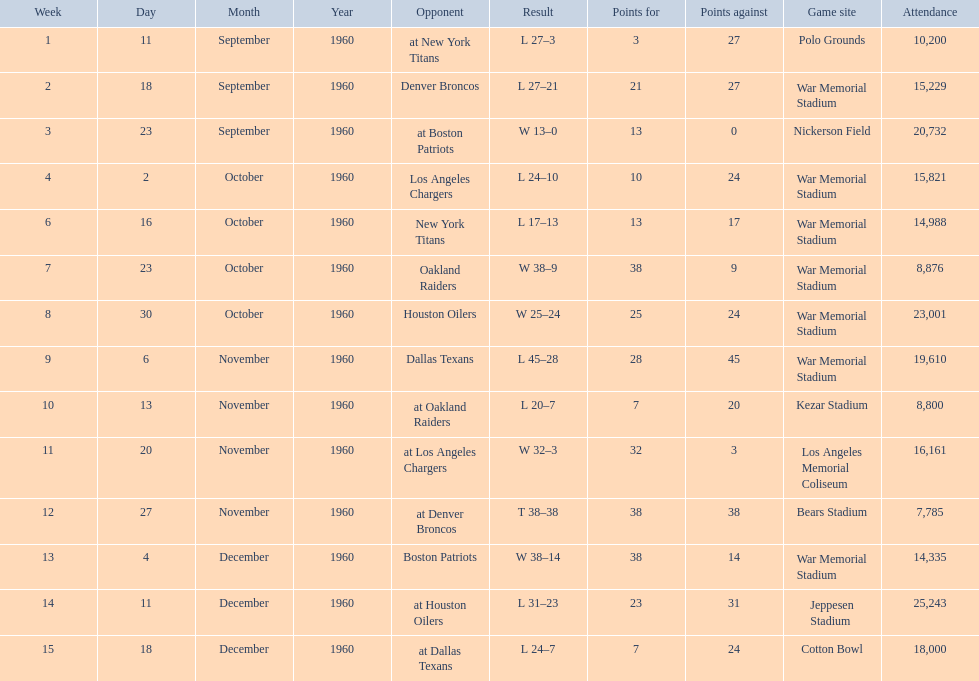How many times was war memorial stadium the game site? 6. 